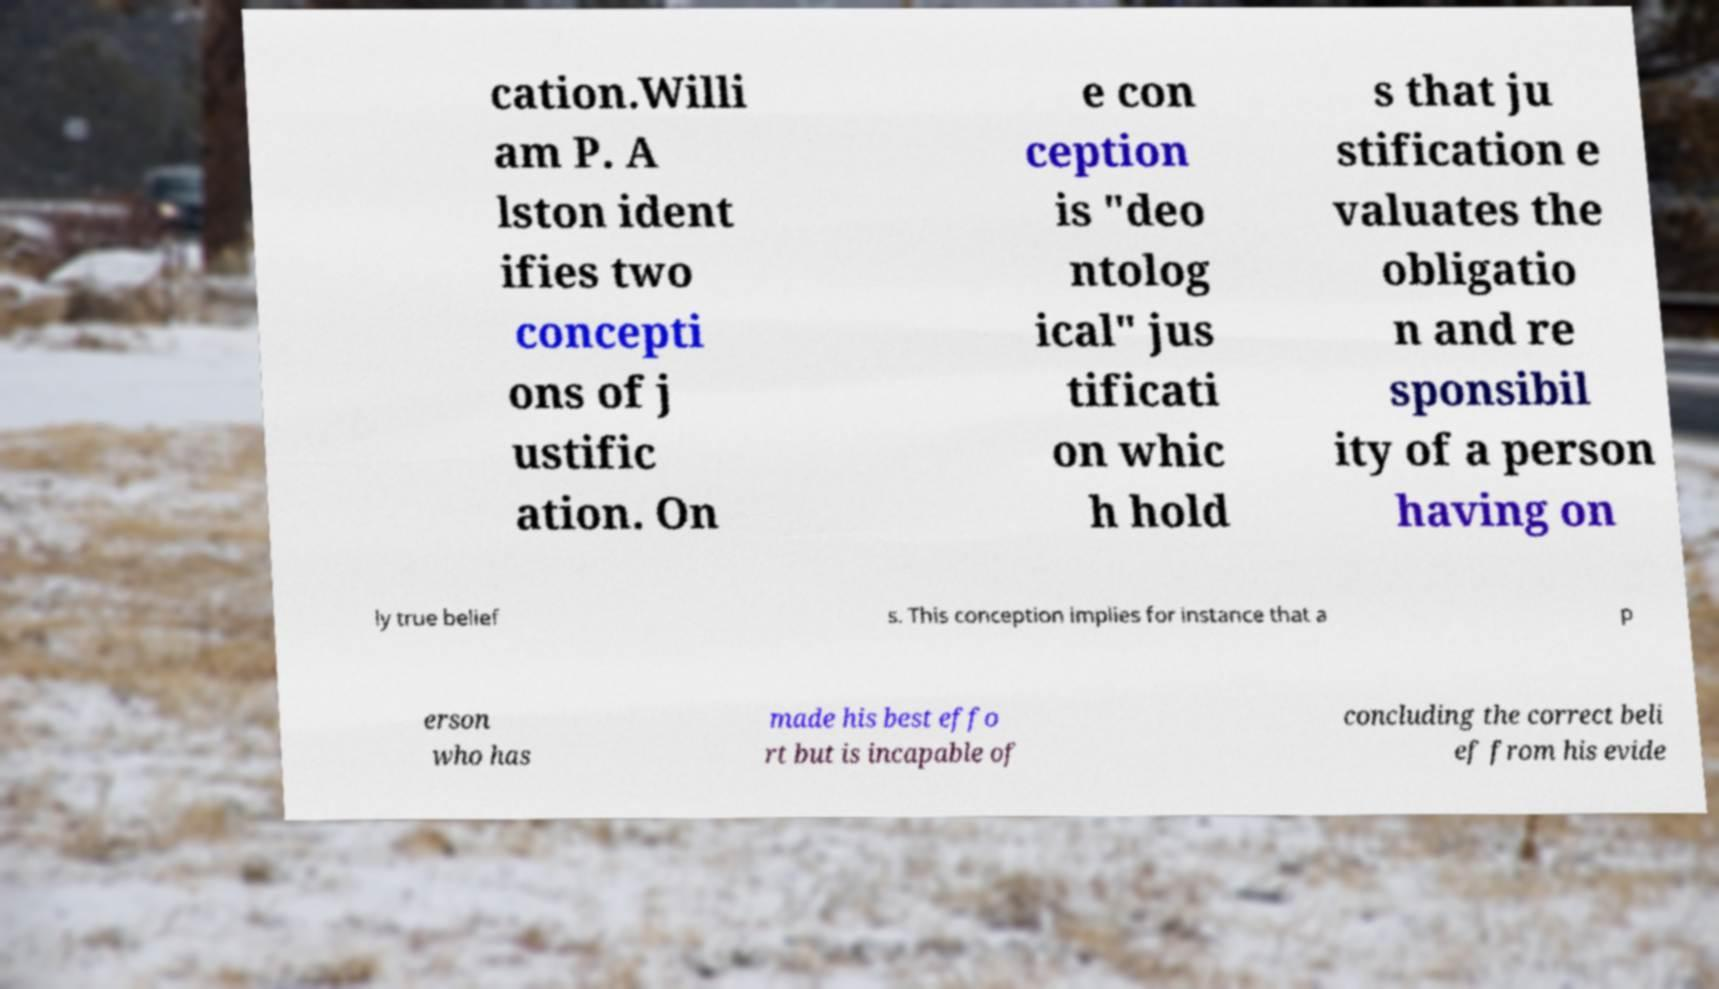Please identify and transcribe the text found in this image. cation.Willi am P. A lston ident ifies two concepti ons of j ustific ation. On e con ception is "deo ntolog ical" jus tificati on whic h hold s that ju stification e valuates the obligatio n and re sponsibil ity of a person having on ly true belief s. This conception implies for instance that a p erson who has made his best effo rt but is incapable of concluding the correct beli ef from his evide 